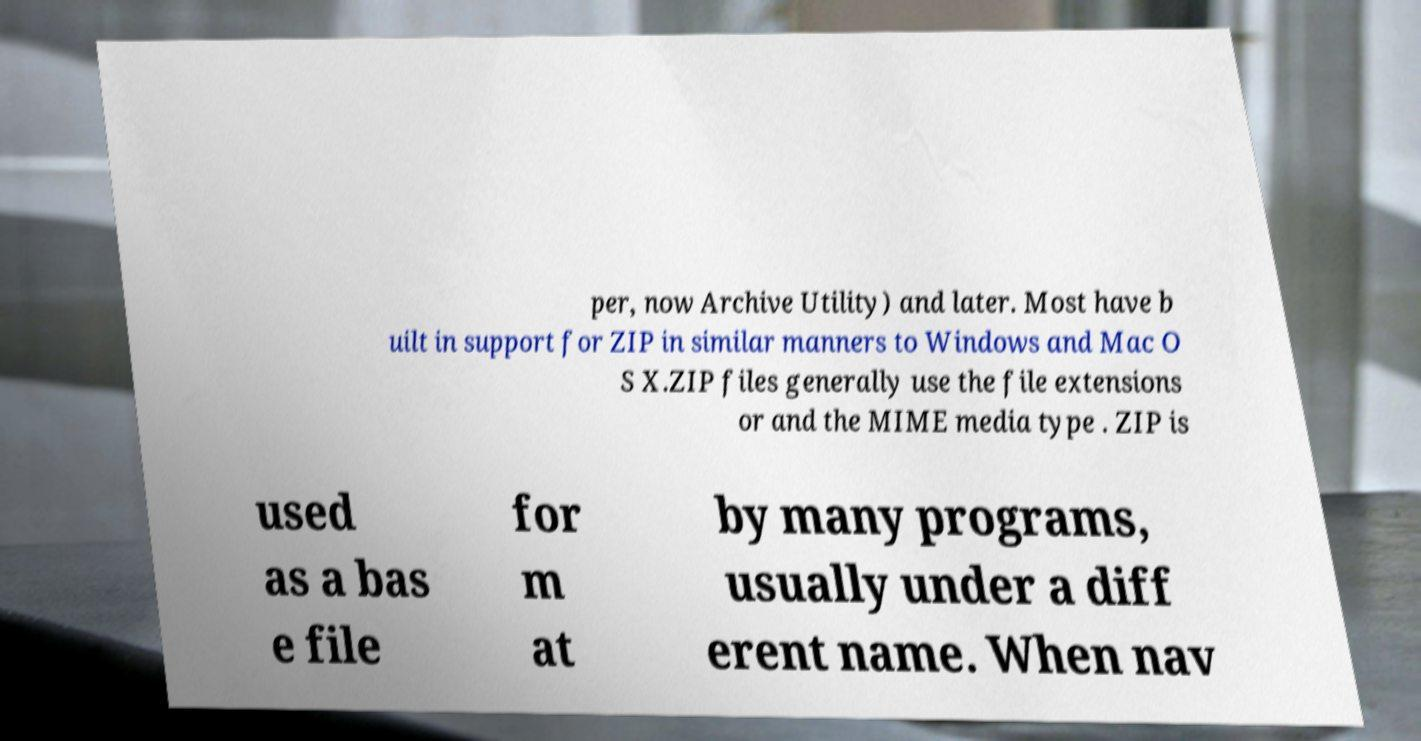Please identify and transcribe the text found in this image. per, now Archive Utility) and later. Most have b uilt in support for ZIP in similar manners to Windows and Mac O S X.ZIP files generally use the file extensions or and the MIME media type . ZIP is used as a bas e file for m at by many programs, usually under a diff erent name. When nav 